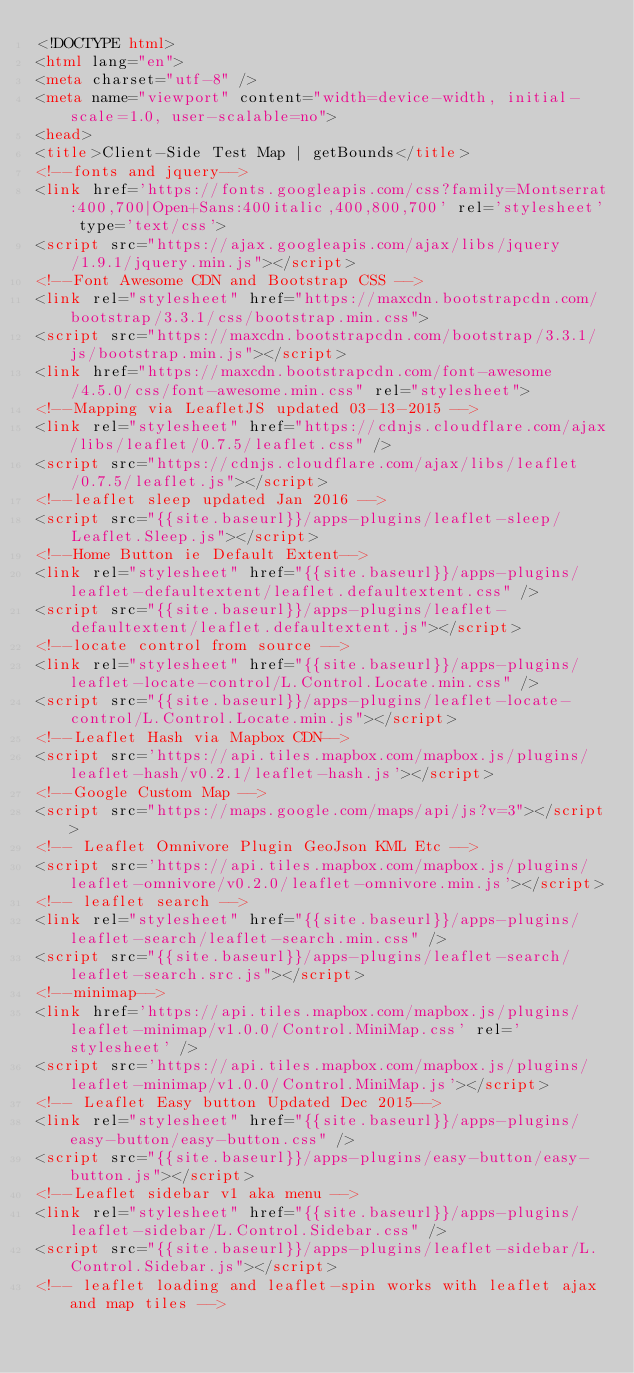Convert code to text. <code><loc_0><loc_0><loc_500><loc_500><_HTML_><!DOCTYPE html>
<html lang="en">
<meta charset="utf-8" />
<meta name="viewport" content="width=device-width, initial-scale=1.0, user-scalable=no">
<head>
<title>Client-Side Test Map | getBounds</title>
<!--fonts and jquery-->
<link href='https://fonts.googleapis.com/css?family=Montserrat:400,700|Open+Sans:400italic,400,800,700' rel='stylesheet' type='text/css'>
<script src="https://ajax.googleapis.com/ajax/libs/jquery/1.9.1/jquery.min.js"></script>
<!--Font Awesome CDN and Bootstrap CSS -->
<link rel="stylesheet" href="https://maxcdn.bootstrapcdn.com/bootstrap/3.3.1/css/bootstrap.min.css">
<script src="https://maxcdn.bootstrapcdn.com/bootstrap/3.3.1/js/bootstrap.min.js"></script>
<link href="https://maxcdn.bootstrapcdn.com/font-awesome/4.5.0/css/font-awesome.min.css" rel="stylesheet">
<!--Mapping via LeafletJS updated 03-13-2015 -->
<link rel="stylesheet" href="https://cdnjs.cloudflare.com/ajax/libs/leaflet/0.7.5/leaflet.css" />
<script src="https://cdnjs.cloudflare.com/ajax/libs/leaflet/0.7.5/leaflet.js"></script>
<!--leaflet sleep updated Jan 2016 -->
<script src="{{site.baseurl}}/apps-plugins/leaflet-sleep/Leaflet.Sleep.js"></script>
<!--Home Button ie Default Extent-->
<link rel="stylesheet" href="{{site.baseurl}}/apps-plugins/leaflet-defaultextent/leaflet.defaultextent.css" />
<script src="{{site.baseurl}}/apps-plugins/leaflet-defaultextent/leaflet.defaultextent.js"></script>
<!--locate control from source -->
<link rel="stylesheet" href="{{site.baseurl}}/apps-plugins/leaflet-locate-control/L.Control.Locate.min.css" />
<script src="{{site.baseurl}}/apps-plugins/leaflet-locate-control/L.Control.Locate.min.js"></script>
<!--Leaflet Hash via Mapbox CDN-->
<script src='https://api.tiles.mapbox.com/mapbox.js/plugins/leaflet-hash/v0.2.1/leaflet-hash.js'></script>
<!--Google Custom Map -->
<script src="https://maps.google.com/maps/api/js?v=3"></script>
<!-- Leaflet Omnivore Plugin GeoJson KML Etc -->
<script src='https://api.tiles.mapbox.com/mapbox.js/plugins/leaflet-omnivore/v0.2.0/leaflet-omnivore.min.js'></script>
<!-- leaflet search -->
<link rel="stylesheet" href="{{site.baseurl}}/apps-plugins/leaflet-search/leaflet-search.min.css" />
<script src="{{site.baseurl}}/apps-plugins/leaflet-search/leaflet-search.src.js"></script>
<!--minimap-->
<link href='https://api.tiles.mapbox.com/mapbox.js/plugins/leaflet-minimap/v1.0.0/Control.MiniMap.css' rel='stylesheet' />
<script src='https://api.tiles.mapbox.com/mapbox.js/plugins/leaflet-minimap/v1.0.0/Control.MiniMap.js'></script>
<!-- Leaflet Easy button Updated Dec 2015-->
<link rel="stylesheet" href="{{site.baseurl}}/apps-plugins/easy-button/easy-button.css" />
<script src="{{site.baseurl}}/apps-plugins/easy-button/easy-button.js"></script>
<!--Leaflet sidebar v1 aka menu -->
<link rel="stylesheet" href="{{site.baseurl}}/apps-plugins/leaflet-sidebar/L.Control.Sidebar.css" />
<script src="{{site.baseurl}}/apps-plugins/leaflet-sidebar/L.Control.Sidebar.js"></script>
<!-- leaflet loading and leaflet-spin works with leaflet ajax and map tiles --></code> 